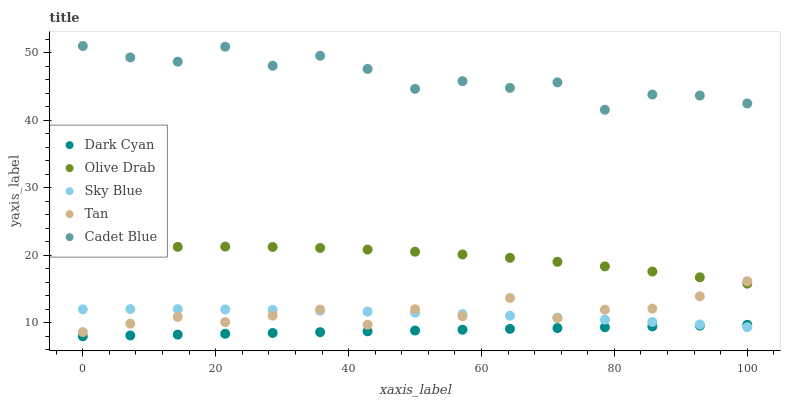Does Dark Cyan have the minimum area under the curve?
Answer yes or no. Yes. Does Cadet Blue have the maximum area under the curve?
Answer yes or no. Yes. Does Sky Blue have the minimum area under the curve?
Answer yes or no. No. Does Sky Blue have the maximum area under the curve?
Answer yes or no. No. Is Dark Cyan the smoothest?
Answer yes or no. Yes. Is Cadet Blue the roughest?
Answer yes or no. Yes. Is Sky Blue the smoothest?
Answer yes or no. No. Is Sky Blue the roughest?
Answer yes or no. No. Does Dark Cyan have the lowest value?
Answer yes or no. Yes. Does Sky Blue have the lowest value?
Answer yes or no. No. Does Cadet Blue have the highest value?
Answer yes or no. Yes. Does Sky Blue have the highest value?
Answer yes or no. No. Is Sky Blue less than Cadet Blue?
Answer yes or no. Yes. Is Cadet Blue greater than Tan?
Answer yes or no. Yes. Does Olive Drab intersect Tan?
Answer yes or no. Yes. Is Olive Drab less than Tan?
Answer yes or no. No. Is Olive Drab greater than Tan?
Answer yes or no. No. Does Sky Blue intersect Cadet Blue?
Answer yes or no. No. 